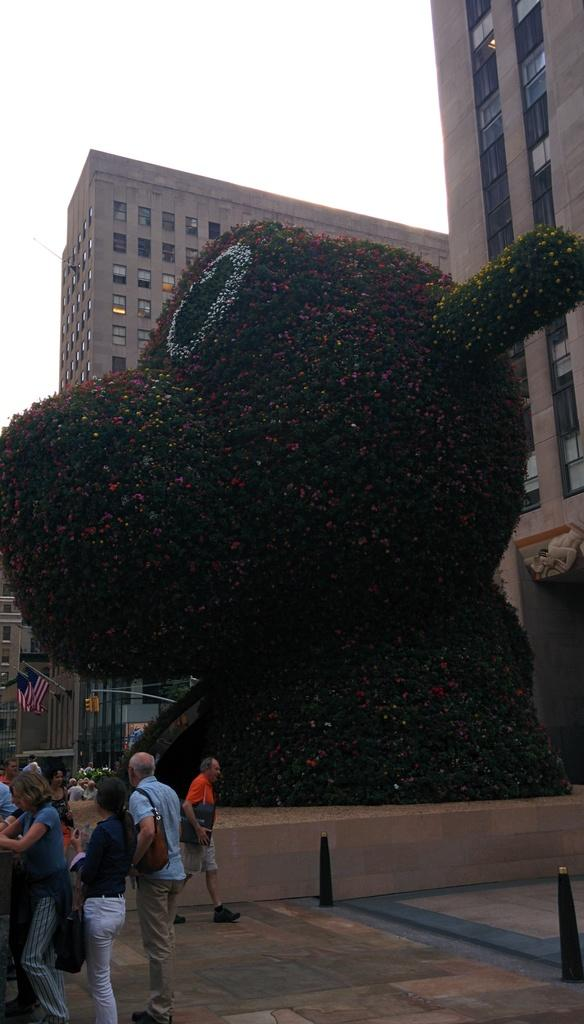What type of structures can be seen in the image? There are buildings in the image. What architectural features can be observed on the buildings? There are windows visible on the buildings. What symbols or markers are present in the image? There are flags and a traffic signal in the image. Are there any people in the image? Yes, there are people in the image. What are some people wearing in the image? Some people are wearing bags. What colors are present in the image? There is a green object, a pink object, and a yellow object in the image. What is the color of the sky in the image? The sky is white in the image. What grade is the teacher giving to the flowers in the image? There are no flowers or teachers present in the image, so it is not possible to determine a grade. What type of leather is visible in the image? There is no leather present in the image. 